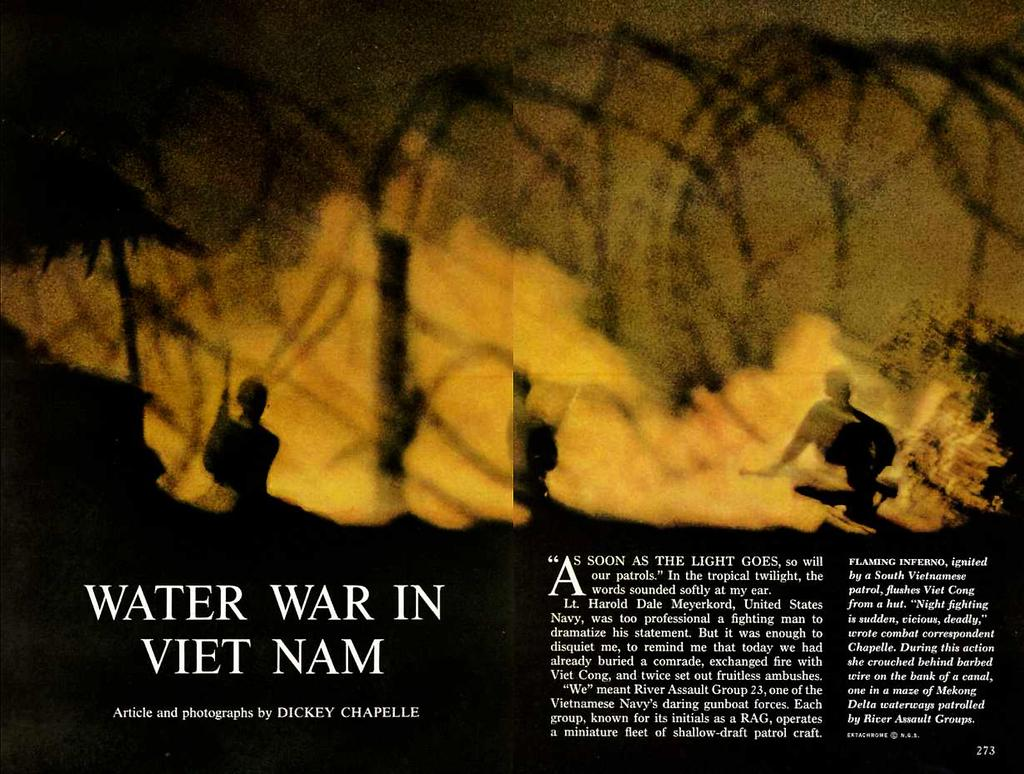<image>
Summarize the visual content of the image. An article has the headline Water War in Vietnam. 